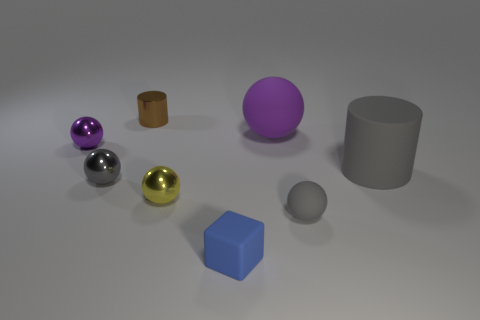There is a object that is behind the blue rubber cube and in front of the yellow metallic object; what is its size?
Offer a terse response. Small. How many large gray cylinders are the same material as the big purple sphere?
Offer a very short reply. 1. What shape is the tiny metal object that is the same color as the large rubber ball?
Your answer should be very brief. Sphere. The cube has what color?
Ensure brevity in your answer.  Blue. Does the gray matte thing behind the yellow metal ball have the same shape as the big purple matte object?
Your answer should be very brief. No. What number of objects are gray things right of the cube or large spheres?
Keep it short and to the point. 3. Are there any other small brown shiny things of the same shape as the brown shiny thing?
Your answer should be compact. No. The purple metallic object that is the same size as the yellow sphere is what shape?
Give a very brief answer. Sphere. The small rubber thing that is behind the matte block in front of the purple sphere that is on the left side of the yellow metal ball is what shape?
Make the answer very short. Sphere. Is the shape of the tiny purple thing the same as the gray thing that is in front of the small yellow metallic ball?
Provide a short and direct response. Yes. 